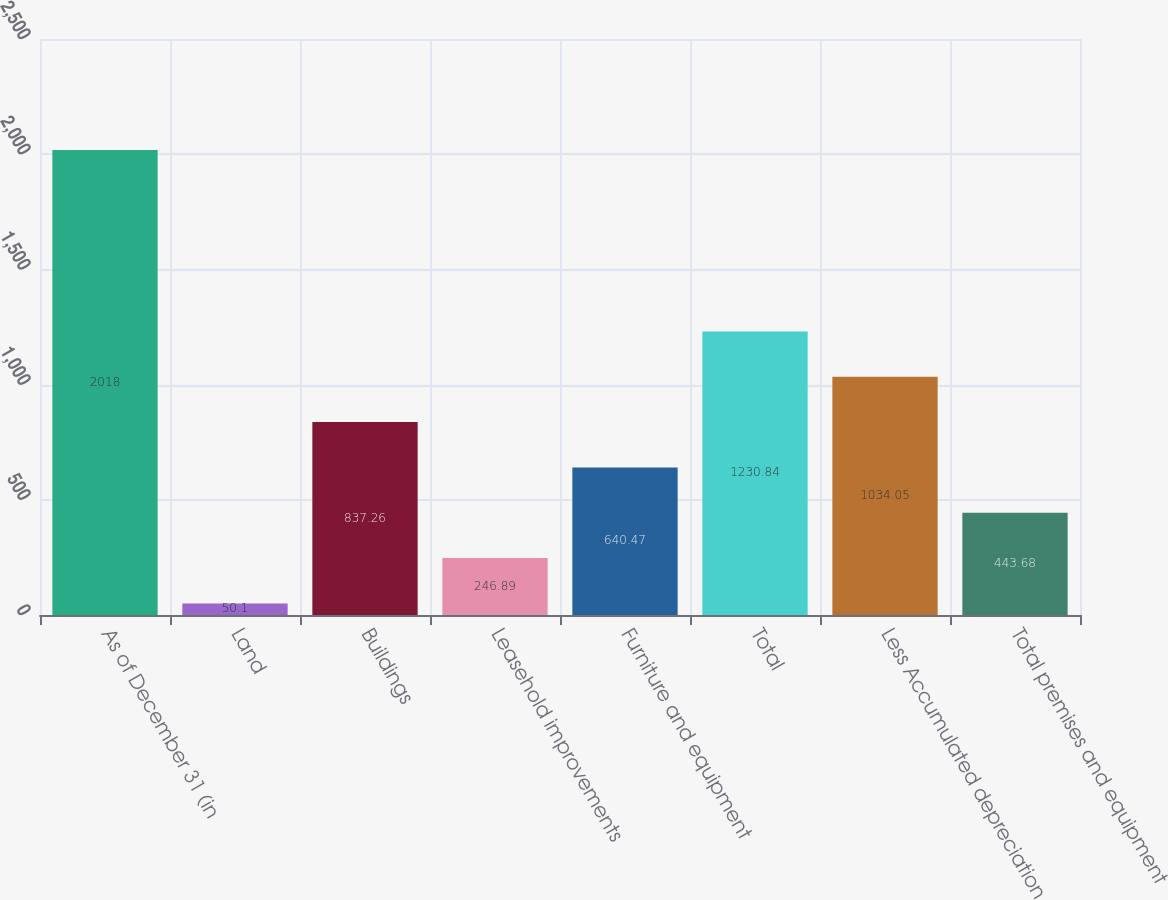<chart> <loc_0><loc_0><loc_500><loc_500><bar_chart><fcel>As of December 31 (in<fcel>Land<fcel>Buildings<fcel>Leasehold improvements<fcel>Furniture and equipment<fcel>Total<fcel>Less Accumulated depreciation<fcel>Total premises and equipment<nl><fcel>2018<fcel>50.1<fcel>837.26<fcel>246.89<fcel>640.47<fcel>1230.84<fcel>1034.05<fcel>443.68<nl></chart> 